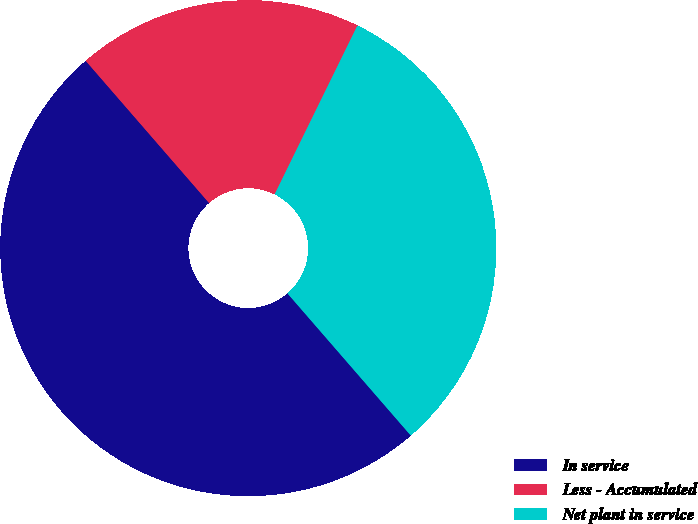<chart> <loc_0><loc_0><loc_500><loc_500><pie_chart><fcel>In service<fcel>Less - Accumulated<fcel>Net plant in service<nl><fcel>50.0%<fcel>18.63%<fcel>31.37%<nl></chart> 